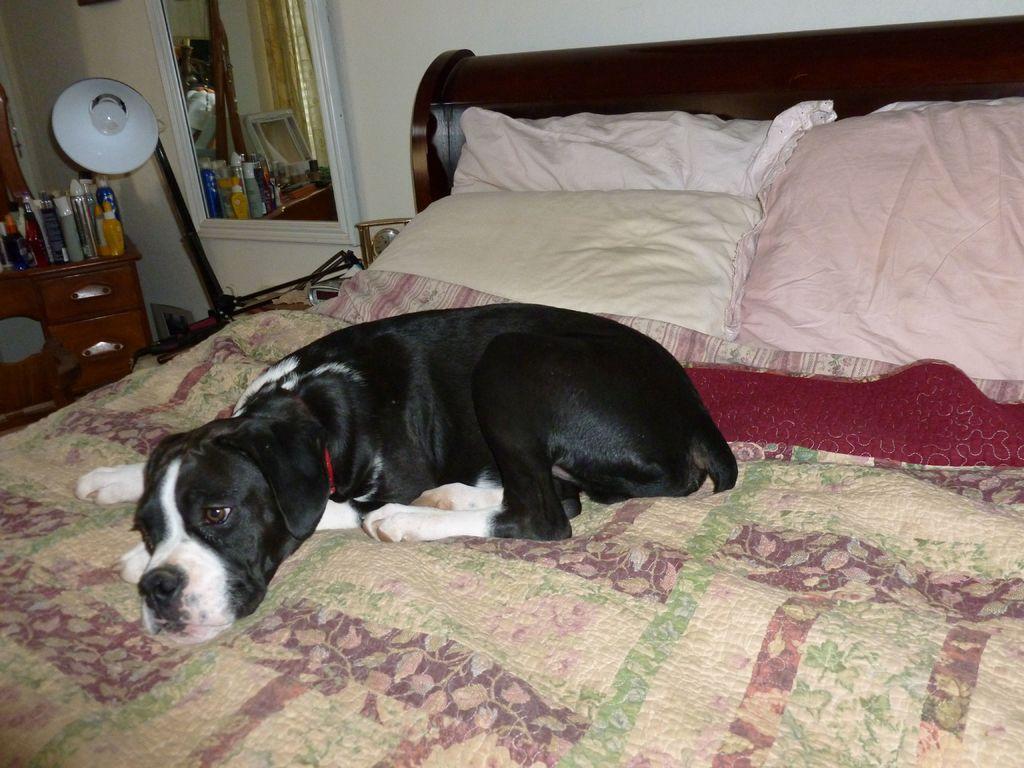Please provide a concise description of this image. We can see dog on the bed. On the background we can see wall,mirror,lamp,table. On the table we can see bottles. we can see pillows. 